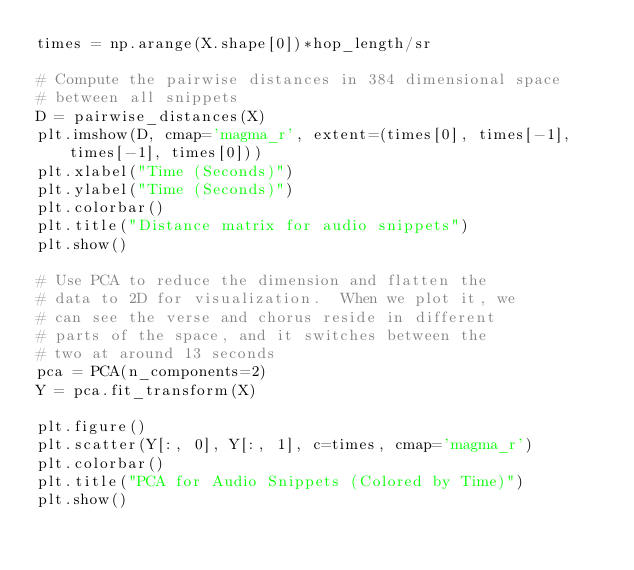<code> <loc_0><loc_0><loc_500><loc_500><_Python_>times = np.arange(X.shape[0])*hop_length/sr

# Compute the pairwise distances in 384 dimensional space
# between all snippets
D = pairwise_distances(X)
plt.imshow(D, cmap='magma_r', extent=(times[0], times[-1], times[-1], times[0]))
plt.xlabel("Time (Seconds)")
plt.ylabel("Time (Seconds)")
plt.colorbar()
plt.title("Distance matrix for audio snippets")
plt.show()

# Use PCA to reduce the dimension and flatten the 
# data to 2D for visualization.  When we plot it, we
# can see the verse and chorus reside in different
# parts of the space, and it switches between the
# two at around 13 seconds
pca = PCA(n_components=2)
Y = pca.fit_transform(X)

plt.figure()
plt.scatter(Y[:, 0], Y[:, 1], c=times, cmap='magma_r')
plt.colorbar()
plt.title("PCA for Audio Snippets (Colored by Time)")
plt.show()
</code> 